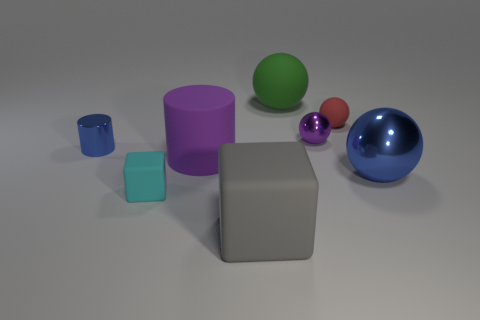Subtract all blue spheres. How many spheres are left? 3 Add 1 balls. How many objects exist? 9 Subtract all blue spheres. How many spheres are left? 3 Subtract 1 cylinders. How many cylinders are left? 1 Add 2 large things. How many large things exist? 6 Subtract 0 red cylinders. How many objects are left? 8 Subtract all cylinders. How many objects are left? 6 Subtract all green blocks. Subtract all red spheres. How many blocks are left? 2 Subtract all large shiny objects. Subtract all big green spheres. How many objects are left? 6 Add 1 gray things. How many gray things are left? 2 